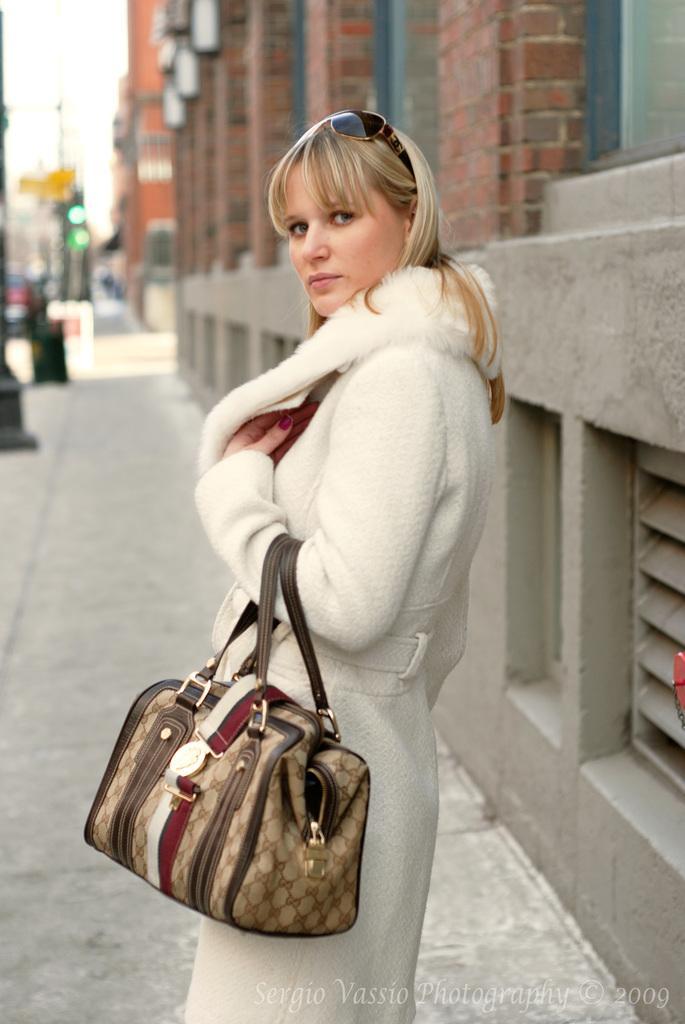In one or two sentences, can you explain what this image depicts? In this image there is a woman who is holding a handbag with her hand and standing. At the background there are buildings,signal light and the pole. 